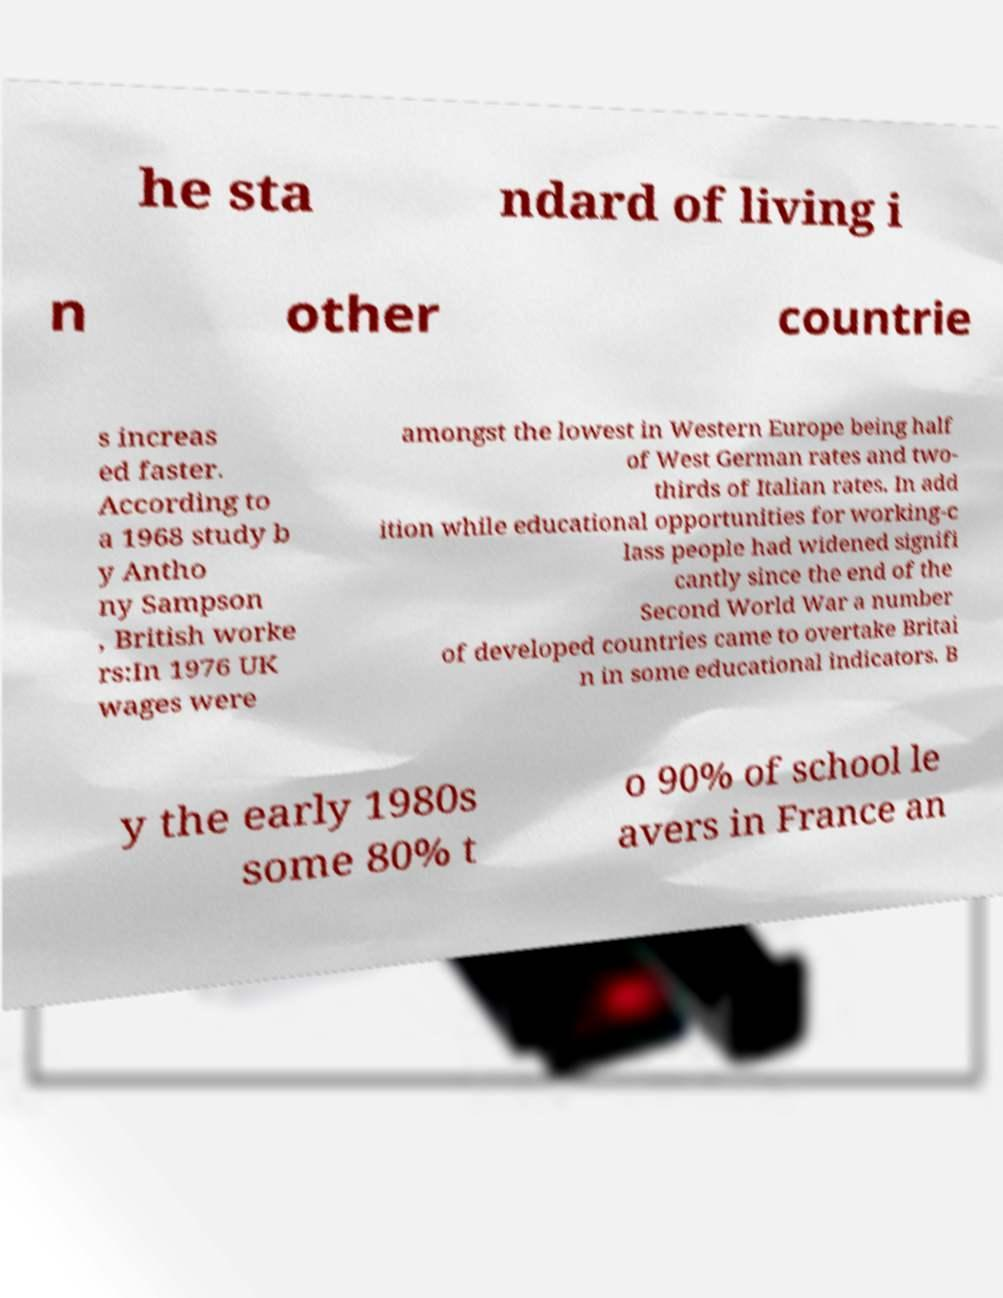Could you assist in decoding the text presented in this image and type it out clearly? he sta ndard of living i n other countrie s increas ed faster. According to a 1968 study b y Antho ny Sampson , British worke rs:In 1976 UK wages were amongst the lowest in Western Europe being half of West German rates and two- thirds of Italian rates. In add ition while educational opportunities for working-c lass people had widened signifi cantly since the end of the Second World War a number of developed countries came to overtake Britai n in some educational indicators. B y the early 1980s some 80% t o 90% of school le avers in France an 